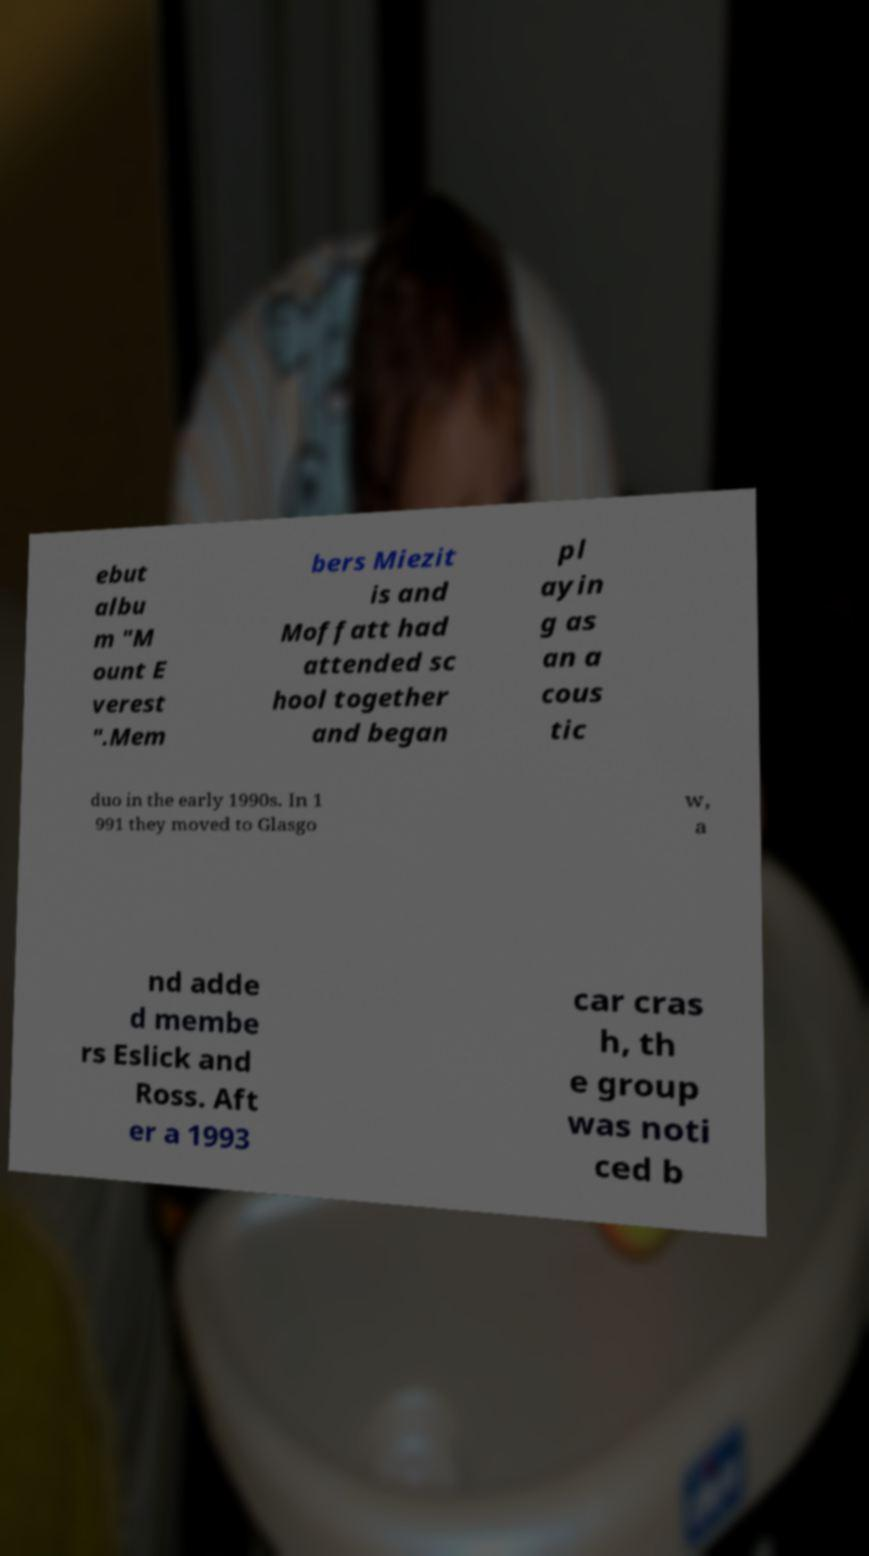I need the written content from this picture converted into text. Can you do that? ebut albu m "M ount E verest ".Mem bers Miezit is and Moffatt had attended sc hool together and began pl ayin g as an a cous tic duo in the early 1990s. In 1 991 they moved to Glasgo w, a nd adde d membe rs Eslick and Ross. Aft er a 1993 car cras h, th e group was noti ced b 